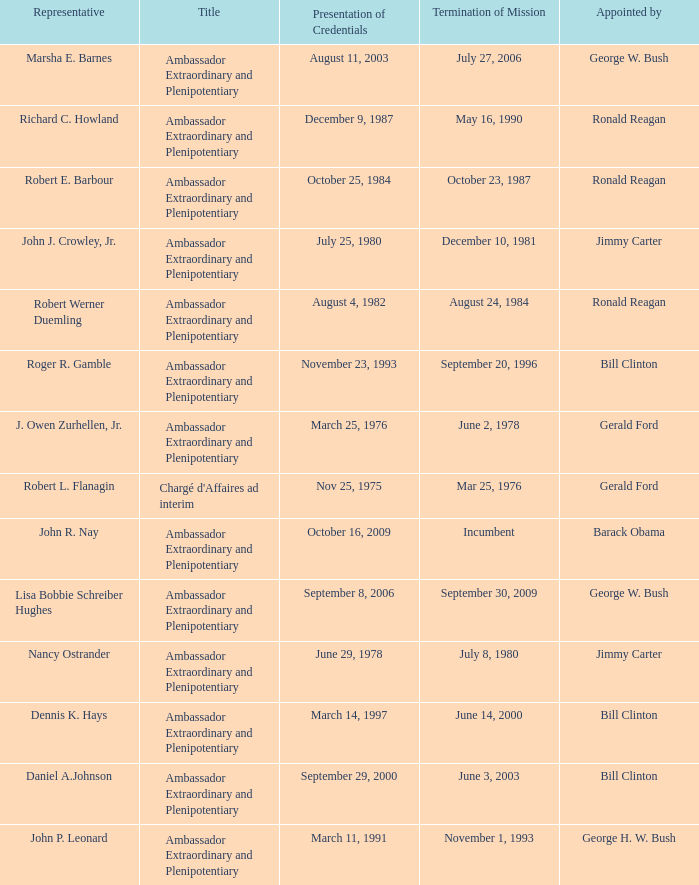Which representative has a Termination of MIssion date Mar 25, 1976? Robert L. Flanagin. 